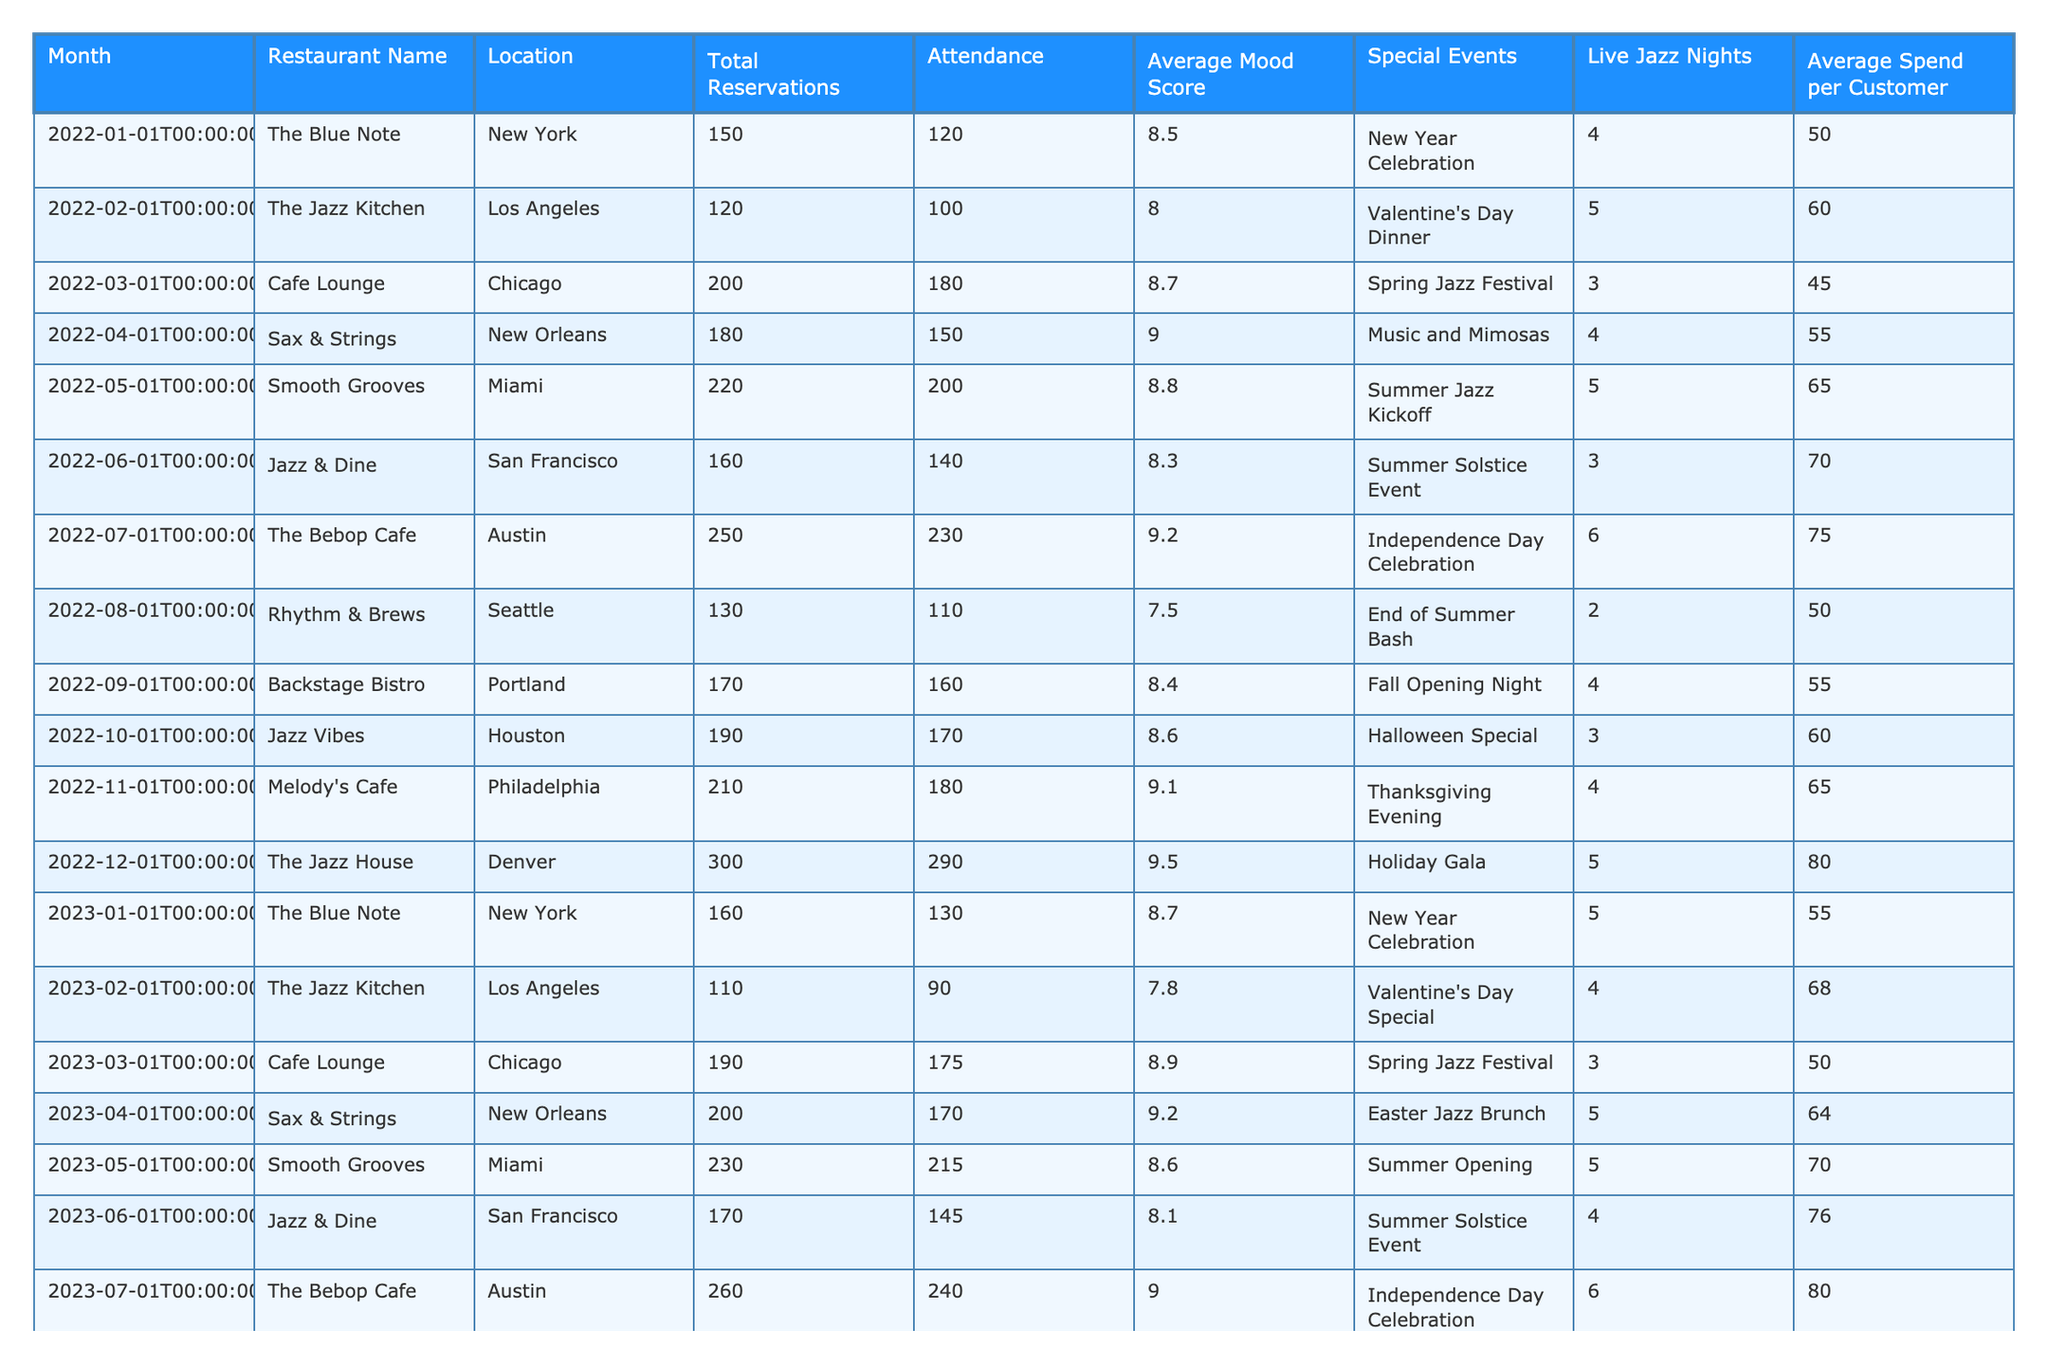What restaurant had the highest total reservations in December 2023? By examining the "Total Reservations" column for December 2023, The Jazz House has the highest number with 320 reservations.
Answer: The Jazz House Which month had the lowest average mood score in 2022? Looking at the "Average Mood Score" column for 2022, the lowest score is 7.5, which occurred in August at Rhythm & Brews.
Answer: August What is the average attendance for live jazz nights across all restaurants in June? To find the average attendance for June, we sum the attendance values for all restaurants in June (140 + 145 + 230) and divide by the number of entries (3), resulting in an average of 171.67, rounded to 172.
Answer: 172 Did Smooth Grooves have a higher average spend per customer in 2023 compared to 2022? In 2023, the average spend per customer at Smooth Grooves is 70, and in 2022, it was 65. Since 70 is greater than 65, the answer is yes.
Answer: Yes What is the total number of reservations for all restaurants in September over the two years? To find the total reservations in September, we sum the values: 170 (2022) + 180 (2023) = 350.
Answer: 350 How many restaurants had a special event in January 2023? Reviewing the "Special Events" column for January 2023, there is one event listed for The Blue Note, which is a New Year Celebration. Thus, the count is 1.
Answer: 1 What was the change in the attendance from July 2022 to July 2023? Attendance in July 2022 was 230 and in July 2023 it was 240. The change is 240 - 230 = 10.
Answer: 10 Which restaurant had the most live jazz nights in 2022, and how many were there? By checking the "Live Jazz Nights" column, The Bebop Cafe had the most with 6 live jazz nights in July 2022.
Answer: The Bebop Cafe, 6 nights What was the average mood score for the restaurants in New Orleans across both years? For New Orleans, the average mood scores are 9.0 (2022) and 9.2 (2023). The average is (9.0 + 9.2) / 2 = 9.1.
Answer: 9.1 Is there any restaurant that had more total reservations in December 2022 compared to December 2023? The total reservations were 300 in December 2022 and 320 in December 2023. Since 320 is greater, the answer is no.
Answer: No 